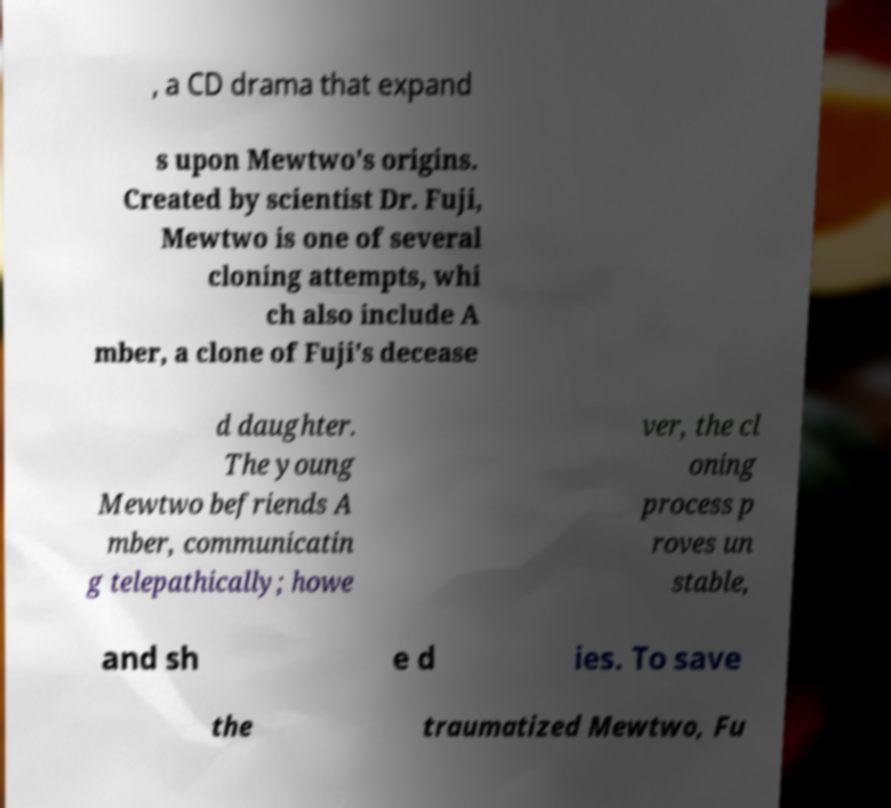Could you extract and type out the text from this image? , a CD drama that expand s upon Mewtwo's origins. Created by scientist Dr. Fuji, Mewtwo is one of several cloning attempts, whi ch also include A mber, a clone of Fuji's decease d daughter. The young Mewtwo befriends A mber, communicatin g telepathically; howe ver, the cl oning process p roves un stable, and sh e d ies. To save the traumatized Mewtwo, Fu 